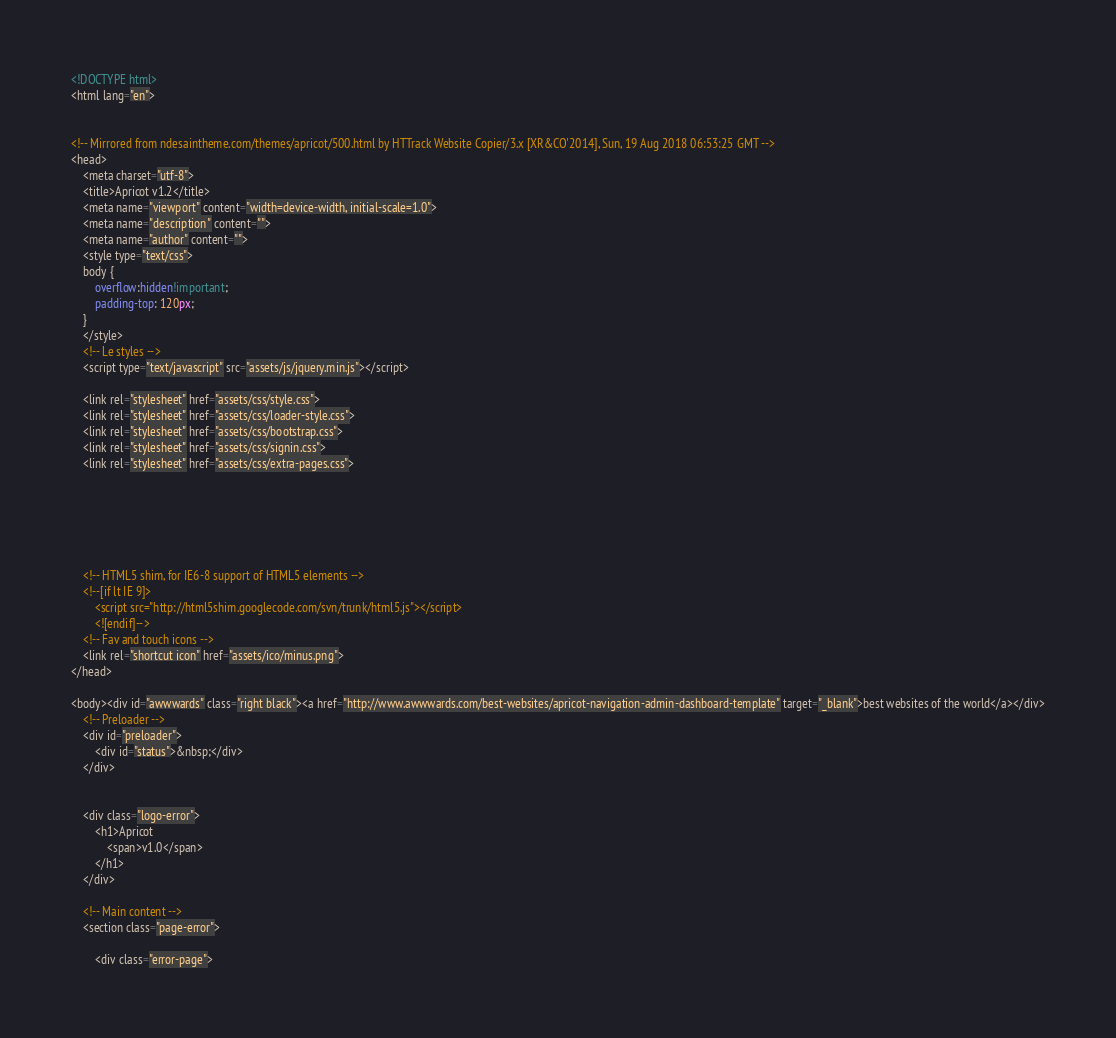Convert code to text. <code><loc_0><loc_0><loc_500><loc_500><_HTML_><!DOCTYPE html>
<html lang="en">


<!-- Mirrored from ndesaintheme.com/themes/apricot/500.html by HTTrack Website Copier/3.x [XR&CO'2014], Sun, 19 Aug 2018 06:53:25 GMT -->
<head>
    <meta charset="utf-8">
    <title>Apricot v1.2</title>
    <meta name="viewport" content="width=device-width, initial-scale=1.0">
    <meta name="description" content="">
    <meta name="author" content="">
    <style type="text/css">
    body {
        overflow:hidden!important;
        padding-top: 120px;
    }
    </style>
    <!-- Le styles -->
    <script type="text/javascript" src="assets/js/jquery.min.js"></script>

    <link rel="stylesheet" href="assets/css/style.css">
    <link rel="stylesheet" href="assets/css/loader-style.css">
    <link rel="stylesheet" href="assets/css/bootstrap.css">
    <link rel="stylesheet" href="assets/css/signin.css">
    <link rel="stylesheet" href="assets/css/extra-pages.css">






    <!-- HTML5 shim, for IE6-8 support of HTML5 elements -->
    <!--[if lt IE 9]>
        <script src="http://html5shim.googlecode.com/svn/trunk/html5.js"></script>
        <![endif]-->
    <!-- Fav and touch icons -->
    <link rel="shortcut icon" href="assets/ico/minus.png">
</head>

<body><div id="awwwards" class="right black"><a href="http://www.awwwards.com/best-websites/apricot-navigation-admin-dashboard-template" target="_blank">best websites of the world</a></div>
    <!-- Preloader -->
    <div id="preloader">
        <div id="status">&nbsp;</div>
    </div>


    <div class="logo-error">
        <h1>Apricot
            <span>v1.0</span>
        </h1>
    </div>

    <!-- Main content -->
    <section class="page-error">

        <div class="error-page"></code> 